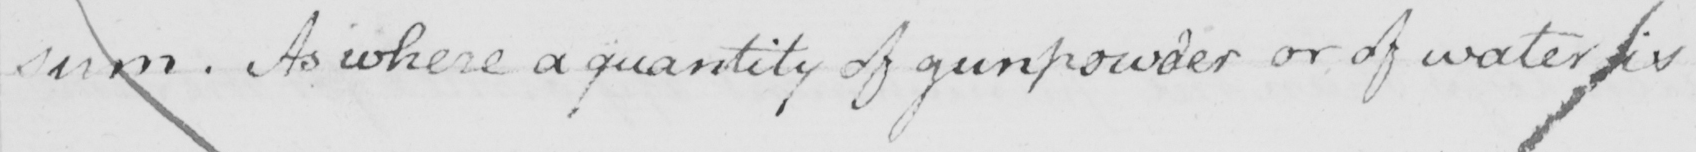What text is written in this handwritten line? sum . As where a quantity of gunpowder or of water is 